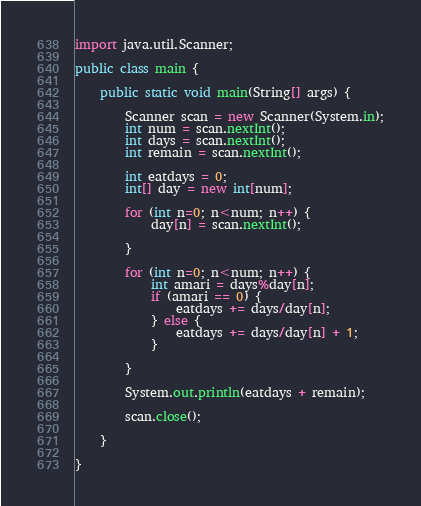Convert code to text. <code><loc_0><loc_0><loc_500><loc_500><_Java_>import java.util.Scanner;

public class main {

	public static void main(String[] args) {

		Scanner scan = new Scanner(System.in);
		int num = scan.nextInt();
		int days = scan.nextInt();
		int remain = scan.nextInt();

		int eatdays = 0;
		int[] day = new int[num];

		for (int n=0; n<num; n++) {
			day[n] = scan.nextInt();

		}

		for (int n=0; n<num; n++) {
			int amari = days%day[n];
			if (amari == 0) {
				eatdays += days/day[n];
			} else {
				eatdays += days/day[n] + 1;
			}

		}

		System.out.println(eatdays + remain);

		scan.close();

	}

}
</code> 